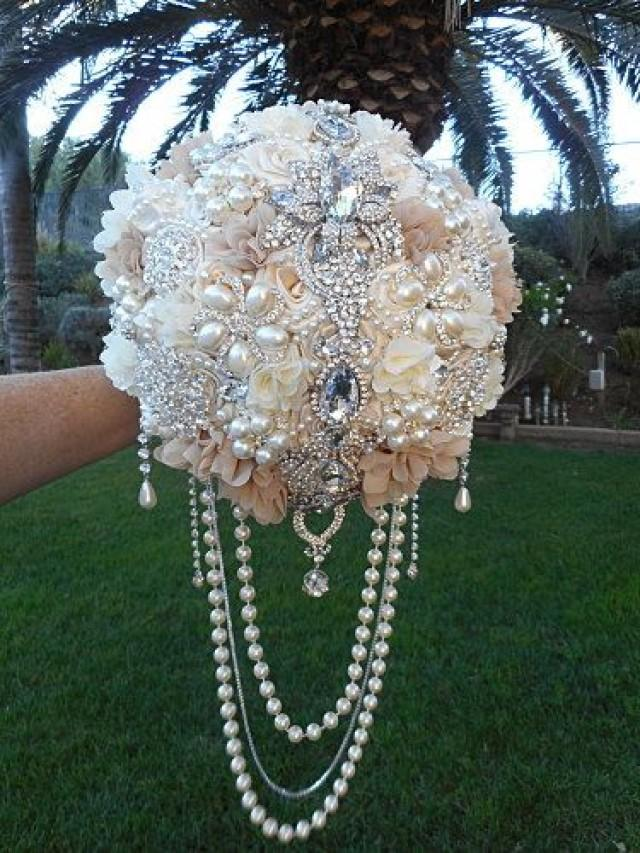What kind of setting or venue would complement this bouquet? A setting that pairs well with this bouquet would likely be opulent and elegant, such as a grand ballroom or a historic mansion with ornate decorations. The sophisticated appeal of the bouquet would be emphasized in a venue with a timeless aesthetic, which might include elements like crystal chandeliers, classic architectural details, and a neutral color palette that matches the bouquet's tones. 